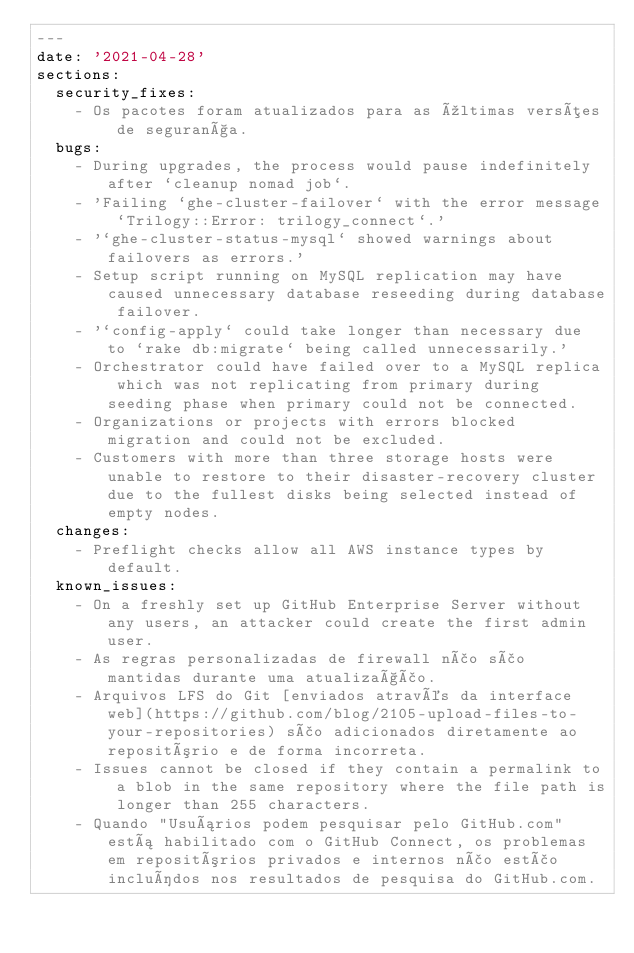Convert code to text. <code><loc_0><loc_0><loc_500><loc_500><_YAML_>---
date: '2021-04-28'
sections:
  security_fixes:
    - Os pacotes foram atualizados para as últimas versões de segurança.
  bugs:
    - During upgrades, the process would pause indefinitely after `cleanup nomad job`.
    - 'Failing `ghe-cluster-failover` with the error message `Trilogy::Error: trilogy_connect`.'
    - '`ghe-cluster-status-mysql` showed warnings about failovers as errors.'
    - Setup script running on MySQL replication may have caused unnecessary database reseeding during database failover.
    - '`config-apply` could take longer than necessary due to `rake db:migrate` being called unnecessarily.'
    - Orchestrator could have failed over to a MySQL replica which was not replicating from primary during seeding phase when primary could not be connected.
    - Organizations or projects with errors blocked migration and could not be excluded.
    - Customers with more than three storage hosts were unable to restore to their disaster-recovery cluster due to the fullest disks being selected instead of empty nodes.
  changes:
    - Preflight checks allow all AWS instance types by default.
  known_issues:
    - On a freshly set up GitHub Enterprise Server without any users, an attacker could create the first admin user.
    - As regras personalizadas de firewall não são mantidas durante uma atualização.
    - Arquivos LFS do Git [enviados através da interface web](https://github.com/blog/2105-upload-files-to-your-repositories) são adicionados diretamente ao repositório e de forma incorreta.
    - Issues cannot be closed if they contain a permalink to a blob in the same repository where the file path is longer than 255 characters.
    - Quando "Usuários podem pesquisar pelo GitHub.com" está habilitado com o GitHub Connect, os problemas em repositórios privados e internos não estão incluídos nos resultados de pesquisa do GitHub.com.
</code> 